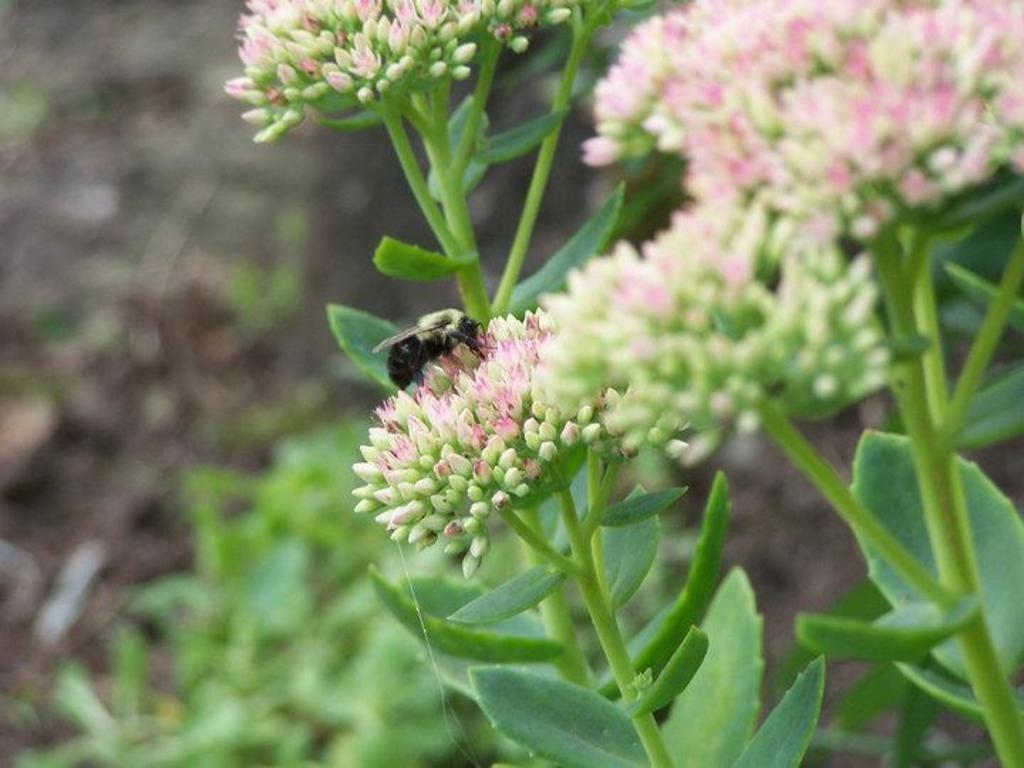What type of plant life is present in the image? There are flowers and green leaves in the image. Can you describe any living organisms in the image? Yes, there is a black insect in the image. How would you characterize the image's focus? The image is slightly blurry in the background. What type of attraction is the rat visiting in the image? There is no rat present in the image, so it is not possible to determine if it is visiting any attraction. 